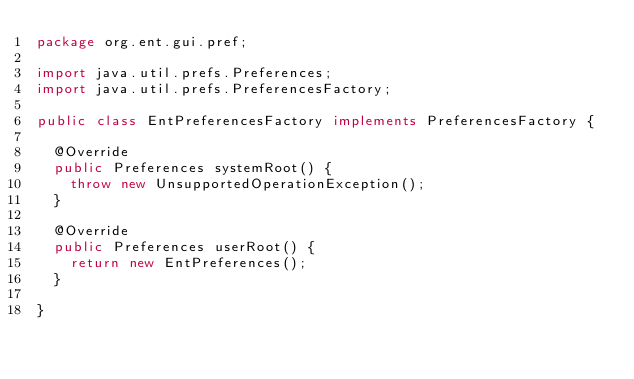Convert code to text. <code><loc_0><loc_0><loc_500><loc_500><_Java_>package org.ent.gui.pref;

import java.util.prefs.Preferences;
import java.util.prefs.PreferencesFactory;

public class EntPreferencesFactory implements PreferencesFactory {

	@Override
	public Preferences systemRoot() {
		throw new UnsupportedOperationException();
	}

	@Override
	public Preferences userRoot() {
		return new EntPreferences();
	}

}
</code> 